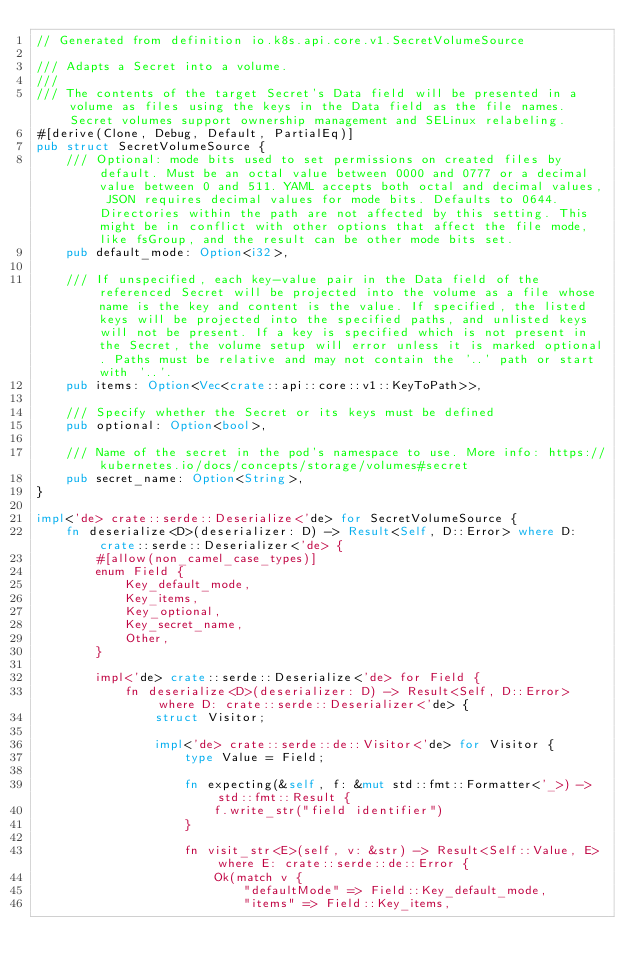Convert code to text. <code><loc_0><loc_0><loc_500><loc_500><_Rust_>// Generated from definition io.k8s.api.core.v1.SecretVolumeSource

/// Adapts a Secret into a volume.
///
/// The contents of the target Secret's Data field will be presented in a volume as files using the keys in the Data field as the file names. Secret volumes support ownership management and SELinux relabeling.
#[derive(Clone, Debug, Default, PartialEq)]
pub struct SecretVolumeSource {
    /// Optional: mode bits used to set permissions on created files by default. Must be an octal value between 0000 and 0777 or a decimal value between 0 and 511. YAML accepts both octal and decimal values, JSON requires decimal values for mode bits. Defaults to 0644. Directories within the path are not affected by this setting. This might be in conflict with other options that affect the file mode, like fsGroup, and the result can be other mode bits set.
    pub default_mode: Option<i32>,

    /// If unspecified, each key-value pair in the Data field of the referenced Secret will be projected into the volume as a file whose name is the key and content is the value. If specified, the listed keys will be projected into the specified paths, and unlisted keys will not be present. If a key is specified which is not present in the Secret, the volume setup will error unless it is marked optional. Paths must be relative and may not contain the '..' path or start with '..'.
    pub items: Option<Vec<crate::api::core::v1::KeyToPath>>,

    /// Specify whether the Secret or its keys must be defined
    pub optional: Option<bool>,

    /// Name of the secret in the pod's namespace to use. More info: https://kubernetes.io/docs/concepts/storage/volumes#secret
    pub secret_name: Option<String>,
}

impl<'de> crate::serde::Deserialize<'de> for SecretVolumeSource {
    fn deserialize<D>(deserializer: D) -> Result<Self, D::Error> where D: crate::serde::Deserializer<'de> {
        #[allow(non_camel_case_types)]
        enum Field {
            Key_default_mode,
            Key_items,
            Key_optional,
            Key_secret_name,
            Other,
        }

        impl<'de> crate::serde::Deserialize<'de> for Field {
            fn deserialize<D>(deserializer: D) -> Result<Self, D::Error> where D: crate::serde::Deserializer<'de> {
                struct Visitor;

                impl<'de> crate::serde::de::Visitor<'de> for Visitor {
                    type Value = Field;

                    fn expecting(&self, f: &mut std::fmt::Formatter<'_>) -> std::fmt::Result {
                        f.write_str("field identifier")
                    }

                    fn visit_str<E>(self, v: &str) -> Result<Self::Value, E> where E: crate::serde::de::Error {
                        Ok(match v {
                            "defaultMode" => Field::Key_default_mode,
                            "items" => Field::Key_items,</code> 